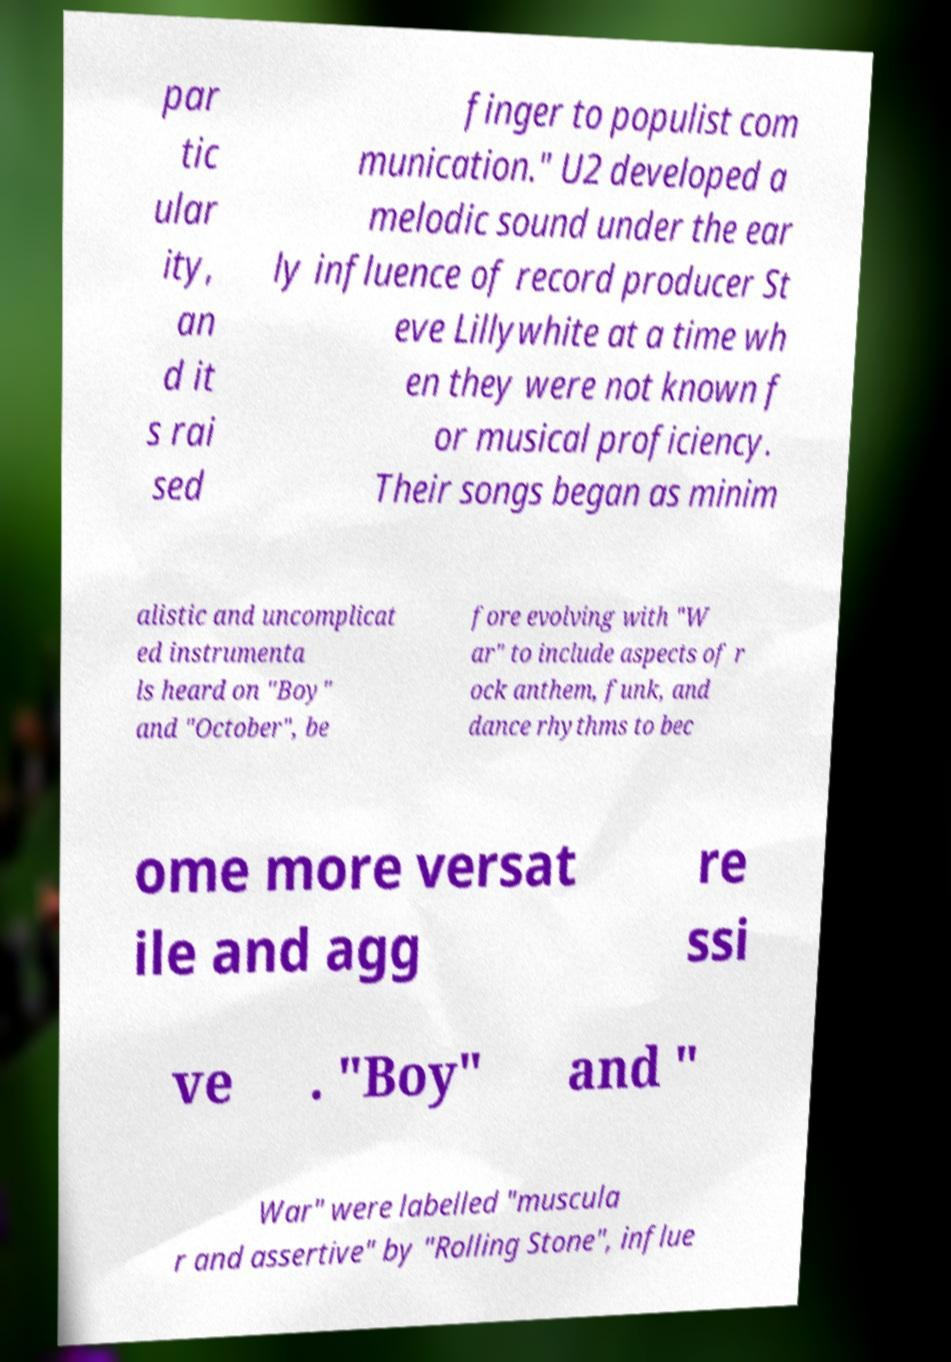I need the written content from this picture converted into text. Can you do that? par tic ular ity, an d it s rai sed finger to populist com munication." U2 developed a melodic sound under the ear ly influence of record producer St eve Lillywhite at a time wh en they were not known f or musical proficiency. Their songs began as minim alistic and uncomplicat ed instrumenta ls heard on "Boy" and "October", be fore evolving with "W ar" to include aspects of r ock anthem, funk, and dance rhythms to bec ome more versat ile and agg re ssi ve . "Boy" and " War" were labelled "muscula r and assertive" by "Rolling Stone", influe 